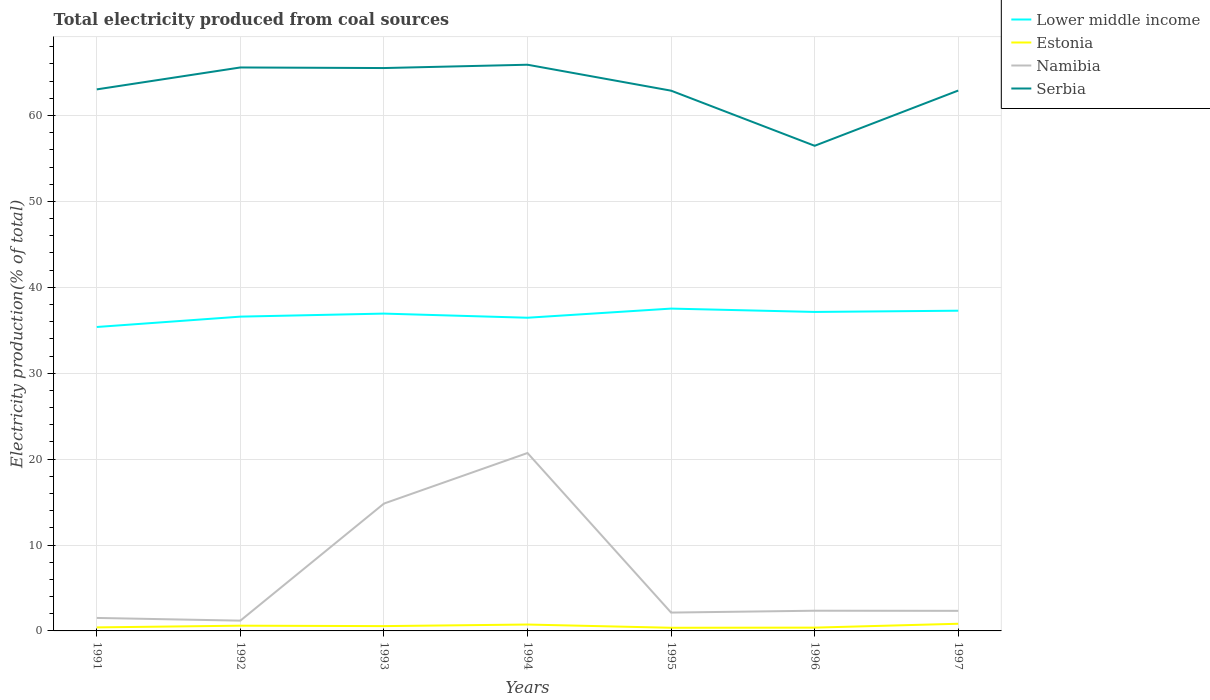Does the line corresponding to Serbia intersect with the line corresponding to Lower middle income?
Give a very brief answer. No. Is the number of lines equal to the number of legend labels?
Your response must be concise. Yes. Across all years, what is the maximum total electricity produced in Serbia?
Your response must be concise. 56.47. In which year was the total electricity produced in Serbia maximum?
Your answer should be very brief. 1996. What is the total total electricity produced in Lower middle income in the graph?
Offer a very short reply. 0.39. What is the difference between the highest and the second highest total electricity produced in Namibia?
Your response must be concise. 19.51. How many lines are there?
Provide a succinct answer. 4. Where does the legend appear in the graph?
Ensure brevity in your answer.  Top right. What is the title of the graph?
Make the answer very short. Total electricity produced from coal sources. Does "Switzerland" appear as one of the legend labels in the graph?
Provide a short and direct response. No. What is the Electricity production(% of total) in Lower middle income in 1991?
Your answer should be very brief. 35.38. What is the Electricity production(% of total) of Estonia in 1991?
Your response must be concise. 0.41. What is the Electricity production(% of total) in Namibia in 1991?
Your answer should be compact. 1.51. What is the Electricity production(% of total) in Serbia in 1991?
Your response must be concise. 63.04. What is the Electricity production(% of total) in Lower middle income in 1992?
Your response must be concise. 36.58. What is the Electricity production(% of total) of Estonia in 1992?
Your response must be concise. 0.61. What is the Electricity production(% of total) in Namibia in 1992?
Your response must be concise. 1.2. What is the Electricity production(% of total) in Serbia in 1992?
Your answer should be compact. 65.59. What is the Electricity production(% of total) of Lower middle income in 1993?
Make the answer very short. 36.94. What is the Electricity production(% of total) in Estonia in 1993?
Give a very brief answer. 0.56. What is the Electricity production(% of total) in Namibia in 1993?
Keep it short and to the point. 14.82. What is the Electricity production(% of total) of Serbia in 1993?
Keep it short and to the point. 65.52. What is the Electricity production(% of total) of Lower middle income in 1994?
Offer a very short reply. 36.46. What is the Electricity production(% of total) in Estonia in 1994?
Ensure brevity in your answer.  0.74. What is the Electricity production(% of total) in Namibia in 1994?
Your answer should be very brief. 20.71. What is the Electricity production(% of total) of Serbia in 1994?
Your answer should be compact. 65.91. What is the Electricity production(% of total) in Lower middle income in 1995?
Your answer should be very brief. 37.52. What is the Electricity production(% of total) of Estonia in 1995?
Provide a short and direct response. 0.37. What is the Electricity production(% of total) in Namibia in 1995?
Your response must be concise. 2.13. What is the Electricity production(% of total) of Serbia in 1995?
Offer a very short reply. 62.89. What is the Electricity production(% of total) of Lower middle income in 1996?
Give a very brief answer. 37.13. What is the Electricity production(% of total) in Estonia in 1996?
Your answer should be very brief. 0.38. What is the Electricity production(% of total) of Namibia in 1996?
Your answer should be compact. 2.35. What is the Electricity production(% of total) in Serbia in 1996?
Offer a very short reply. 56.47. What is the Electricity production(% of total) in Lower middle income in 1997?
Provide a succinct answer. 37.27. What is the Electricity production(% of total) of Estonia in 1997?
Offer a very short reply. 0.84. What is the Electricity production(% of total) in Namibia in 1997?
Keep it short and to the point. 2.34. What is the Electricity production(% of total) of Serbia in 1997?
Ensure brevity in your answer.  62.9. Across all years, what is the maximum Electricity production(% of total) in Lower middle income?
Ensure brevity in your answer.  37.52. Across all years, what is the maximum Electricity production(% of total) in Estonia?
Give a very brief answer. 0.84. Across all years, what is the maximum Electricity production(% of total) in Namibia?
Your answer should be compact. 20.71. Across all years, what is the maximum Electricity production(% of total) in Serbia?
Make the answer very short. 65.91. Across all years, what is the minimum Electricity production(% of total) in Lower middle income?
Your answer should be compact. 35.38. Across all years, what is the minimum Electricity production(% of total) in Estonia?
Your response must be concise. 0.37. Across all years, what is the minimum Electricity production(% of total) in Namibia?
Keep it short and to the point. 1.2. Across all years, what is the minimum Electricity production(% of total) in Serbia?
Offer a terse response. 56.47. What is the total Electricity production(% of total) of Lower middle income in the graph?
Your answer should be very brief. 257.28. What is the total Electricity production(% of total) in Estonia in the graph?
Make the answer very short. 3.91. What is the total Electricity production(% of total) of Namibia in the graph?
Your response must be concise. 45.07. What is the total Electricity production(% of total) of Serbia in the graph?
Your answer should be compact. 442.32. What is the difference between the Electricity production(% of total) in Lower middle income in 1991 and that in 1992?
Offer a very short reply. -1.21. What is the difference between the Electricity production(% of total) in Estonia in 1991 and that in 1992?
Your answer should be very brief. -0.2. What is the difference between the Electricity production(% of total) in Namibia in 1991 and that in 1992?
Your answer should be very brief. 0.32. What is the difference between the Electricity production(% of total) of Serbia in 1991 and that in 1992?
Your answer should be compact. -2.55. What is the difference between the Electricity production(% of total) of Lower middle income in 1991 and that in 1993?
Your answer should be compact. -1.56. What is the difference between the Electricity production(% of total) in Estonia in 1991 and that in 1993?
Offer a terse response. -0.15. What is the difference between the Electricity production(% of total) of Namibia in 1991 and that in 1993?
Offer a terse response. -13.31. What is the difference between the Electricity production(% of total) of Serbia in 1991 and that in 1993?
Keep it short and to the point. -2.48. What is the difference between the Electricity production(% of total) in Lower middle income in 1991 and that in 1994?
Make the answer very short. -1.08. What is the difference between the Electricity production(% of total) in Estonia in 1991 and that in 1994?
Keep it short and to the point. -0.33. What is the difference between the Electricity production(% of total) in Namibia in 1991 and that in 1994?
Your answer should be very brief. -19.2. What is the difference between the Electricity production(% of total) in Serbia in 1991 and that in 1994?
Provide a succinct answer. -2.87. What is the difference between the Electricity production(% of total) in Lower middle income in 1991 and that in 1995?
Ensure brevity in your answer.  -2.14. What is the difference between the Electricity production(% of total) in Estonia in 1991 and that in 1995?
Ensure brevity in your answer.  0.04. What is the difference between the Electricity production(% of total) in Namibia in 1991 and that in 1995?
Keep it short and to the point. -0.62. What is the difference between the Electricity production(% of total) of Lower middle income in 1991 and that in 1996?
Offer a terse response. -1.75. What is the difference between the Electricity production(% of total) in Estonia in 1991 and that in 1996?
Ensure brevity in your answer.  0.03. What is the difference between the Electricity production(% of total) of Namibia in 1991 and that in 1996?
Provide a succinct answer. -0.84. What is the difference between the Electricity production(% of total) of Serbia in 1991 and that in 1996?
Provide a succinct answer. 6.57. What is the difference between the Electricity production(% of total) of Lower middle income in 1991 and that in 1997?
Provide a succinct answer. -1.9. What is the difference between the Electricity production(% of total) of Estonia in 1991 and that in 1997?
Provide a succinct answer. -0.43. What is the difference between the Electricity production(% of total) in Namibia in 1991 and that in 1997?
Your answer should be very brief. -0.82. What is the difference between the Electricity production(% of total) in Serbia in 1991 and that in 1997?
Make the answer very short. 0.14. What is the difference between the Electricity production(% of total) in Lower middle income in 1992 and that in 1993?
Provide a short and direct response. -0.35. What is the difference between the Electricity production(% of total) in Estonia in 1992 and that in 1993?
Provide a short and direct response. 0.05. What is the difference between the Electricity production(% of total) in Namibia in 1992 and that in 1993?
Provide a succinct answer. -13.63. What is the difference between the Electricity production(% of total) in Serbia in 1992 and that in 1993?
Provide a succinct answer. 0.07. What is the difference between the Electricity production(% of total) in Lower middle income in 1992 and that in 1994?
Provide a succinct answer. 0.13. What is the difference between the Electricity production(% of total) in Estonia in 1992 and that in 1994?
Provide a short and direct response. -0.13. What is the difference between the Electricity production(% of total) in Namibia in 1992 and that in 1994?
Ensure brevity in your answer.  -19.51. What is the difference between the Electricity production(% of total) of Serbia in 1992 and that in 1994?
Keep it short and to the point. -0.32. What is the difference between the Electricity production(% of total) of Lower middle income in 1992 and that in 1995?
Offer a very short reply. -0.94. What is the difference between the Electricity production(% of total) in Estonia in 1992 and that in 1995?
Your answer should be compact. 0.24. What is the difference between the Electricity production(% of total) of Namibia in 1992 and that in 1995?
Make the answer very short. -0.94. What is the difference between the Electricity production(% of total) of Serbia in 1992 and that in 1995?
Your answer should be compact. 2.7. What is the difference between the Electricity production(% of total) in Lower middle income in 1992 and that in 1996?
Offer a very short reply. -0.55. What is the difference between the Electricity production(% of total) of Estonia in 1992 and that in 1996?
Provide a short and direct response. 0.22. What is the difference between the Electricity production(% of total) of Namibia in 1992 and that in 1996?
Offer a very short reply. -1.16. What is the difference between the Electricity production(% of total) in Serbia in 1992 and that in 1996?
Provide a short and direct response. 9.12. What is the difference between the Electricity production(% of total) of Lower middle income in 1992 and that in 1997?
Offer a very short reply. -0.69. What is the difference between the Electricity production(% of total) of Estonia in 1992 and that in 1997?
Give a very brief answer. -0.23. What is the difference between the Electricity production(% of total) of Namibia in 1992 and that in 1997?
Keep it short and to the point. -1.14. What is the difference between the Electricity production(% of total) of Serbia in 1992 and that in 1997?
Make the answer very short. 2.69. What is the difference between the Electricity production(% of total) in Lower middle income in 1993 and that in 1994?
Ensure brevity in your answer.  0.48. What is the difference between the Electricity production(% of total) in Estonia in 1993 and that in 1994?
Offer a terse response. -0.18. What is the difference between the Electricity production(% of total) of Namibia in 1993 and that in 1994?
Your answer should be compact. -5.88. What is the difference between the Electricity production(% of total) of Serbia in 1993 and that in 1994?
Give a very brief answer. -0.39. What is the difference between the Electricity production(% of total) of Lower middle income in 1993 and that in 1995?
Your answer should be compact. -0.58. What is the difference between the Electricity production(% of total) of Estonia in 1993 and that in 1995?
Make the answer very short. 0.19. What is the difference between the Electricity production(% of total) in Namibia in 1993 and that in 1995?
Your answer should be compact. 12.69. What is the difference between the Electricity production(% of total) in Serbia in 1993 and that in 1995?
Your answer should be very brief. 2.63. What is the difference between the Electricity production(% of total) of Lower middle income in 1993 and that in 1996?
Give a very brief answer. -0.19. What is the difference between the Electricity production(% of total) of Estonia in 1993 and that in 1996?
Your answer should be very brief. 0.17. What is the difference between the Electricity production(% of total) of Namibia in 1993 and that in 1996?
Your answer should be very brief. 12.47. What is the difference between the Electricity production(% of total) in Serbia in 1993 and that in 1996?
Your answer should be compact. 9.05. What is the difference between the Electricity production(% of total) in Lower middle income in 1993 and that in 1997?
Make the answer very short. -0.34. What is the difference between the Electricity production(% of total) in Estonia in 1993 and that in 1997?
Offer a terse response. -0.28. What is the difference between the Electricity production(% of total) of Namibia in 1993 and that in 1997?
Ensure brevity in your answer.  12.49. What is the difference between the Electricity production(% of total) in Serbia in 1993 and that in 1997?
Keep it short and to the point. 2.62. What is the difference between the Electricity production(% of total) in Lower middle income in 1994 and that in 1995?
Make the answer very short. -1.06. What is the difference between the Electricity production(% of total) of Estonia in 1994 and that in 1995?
Your answer should be compact. 0.37. What is the difference between the Electricity production(% of total) of Namibia in 1994 and that in 1995?
Provide a short and direct response. 18.57. What is the difference between the Electricity production(% of total) in Serbia in 1994 and that in 1995?
Keep it short and to the point. 3.02. What is the difference between the Electricity production(% of total) of Lower middle income in 1994 and that in 1996?
Your answer should be very brief. -0.67. What is the difference between the Electricity production(% of total) of Estonia in 1994 and that in 1996?
Your response must be concise. 0.36. What is the difference between the Electricity production(% of total) in Namibia in 1994 and that in 1996?
Offer a terse response. 18.36. What is the difference between the Electricity production(% of total) of Serbia in 1994 and that in 1996?
Your answer should be very brief. 9.44. What is the difference between the Electricity production(% of total) in Lower middle income in 1994 and that in 1997?
Provide a short and direct response. -0.82. What is the difference between the Electricity production(% of total) in Estonia in 1994 and that in 1997?
Offer a terse response. -0.09. What is the difference between the Electricity production(% of total) of Namibia in 1994 and that in 1997?
Offer a very short reply. 18.37. What is the difference between the Electricity production(% of total) in Serbia in 1994 and that in 1997?
Keep it short and to the point. 3.01. What is the difference between the Electricity production(% of total) of Lower middle income in 1995 and that in 1996?
Offer a very short reply. 0.39. What is the difference between the Electricity production(% of total) in Estonia in 1995 and that in 1996?
Your response must be concise. -0.02. What is the difference between the Electricity production(% of total) in Namibia in 1995 and that in 1996?
Provide a succinct answer. -0.22. What is the difference between the Electricity production(% of total) of Serbia in 1995 and that in 1996?
Make the answer very short. 6.42. What is the difference between the Electricity production(% of total) in Lower middle income in 1995 and that in 1997?
Your answer should be very brief. 0.25. What is the difference between the Electricity production(% of total) in Estonia in 1995 and that in 1997?
Keep it short and to the point. -0.47. What is the difference between the Electricity production(% of total) of Namibia in 1995 and that in 1997?
Keep it short and to the point. -0.2. What is the difference between the Electricity production(% of total) of Serbia in 1995 and that in 1997?
Keep it short and to the point. -0.01. What is the difference between the Electricity production(% of total) in Lower middle income in 1996 and that in 1997?
Make the answer very short. -0.14. What is the difference between the Electricity production(% of total) of Estonia in 1996 and that in 1997?
Provide a succinct answer. -0.45. What is the difference between the Electricity production(% of total) of Namibia in 1996 and that in 1997?
Provide a short and direct response. 0.02. What is the difference between the Electricity production(% of total) in Serbia in 1996 and that in 1997?
Your answer should be compact. -6.43. What is the difference between the Electricity production(% of total) in Lower middle income in 1991 and the Electricity production(% of total) in Estonia in 1992?
Make the answer very short. 34.77. What is the difference between the Electricity production(% of total) in Lower middle income in 1991 and the Electricity production(% of total) in Namibia in 1992?
Keep it short and to the point. 34.18. What is the difference between the Electricity production(% of total) in Lower middle income in 1991 and the Electricity production(% of total) in Serbia in 1992?
Provide a succinct answer. -30.21. What is the difference between the Electricity production(% of total) in Estonia in 1991 and the Electricity production(% of total) in Namibia in 1992?
Offer a very short reply. -0.79. What is the difference between the Electricity production(% of total) of Estonia in 1991 and the Electricity production(% of total) of Serbia in 1992?
Your response must be concise. -65.18. What is the difference between the Electricity production(% of total) in Namibia in 1991 and the Electricity production(% of total) in Serbia in 1992?
Keep it short and to the point. -64.08. What is the difference between the Electricity production(% of total) in Lower middle income in 1991 and the Electricity production(% of total) in Estonia in 1993?
Provide a succinct answer. 34.82. What is the difference between the Electricity production(% of total) in Lower middle income in 1991 and the Electricity production(% of total) in Namibia in 1993?
Provide a short and direct response. 20.55. What is the difference between the Electricity production(% of total) of Lower middle income in 1991 and the Electricity production(% of total) of Serbia in 1993?
Provide a short and direct response. -30.14. What is the difference between the Electricity production(% of total) of Estonia in 1991 and the Electricity production(% of total) of Namibia in 1993?
Your answer should be very brief. -14.41. What is the difference between the Electricity production(% of total) of Estonia in 1991 and the Electricity production(% of total) of Serbia in 1993?
Offer a very short reply. -65.11. What is the difference between the Electricity production(% of total) of Namibia in 1991 and the Electricity production(% of total) of Serbia in 1993?
Keep it short and to the point. -64.01. What is the difference between the Electricity production(% of total) of Lower middle income in 1991 and the Electricity production(% of total) of Estonia in 1994?
Offer a very short reply. 34.64. What is the difference between the Electricity production(% of total) in Lower middle income in 1991 and the Electricity production(% of total) in Namibia in 1994?
Offer a terse response. 14.67. What is the difference between the Electricity production(% of total) of Lower middle income in 1991 and the Electricity production(% of total) of Serbia in 1994?
Keep it short and to the point. -30.53. What is the difference between the Electricity production(% of total) in Estonia in 1991 and the Electricity production(% of total) in Namibia in 1994?
Ensure brevity in your answer.  -20.3. What is the difference between the Electricity production(% of total) of Estonia in 1991 and the Electricity production(% of total) of Serbia in 1994?
Provide a short and direct response. -65.5. What is the difference between the Electricity production(% of total) of Namibia in 1991 and the Electricity production(% of total) of Serbia in 1994?
Keep it short and to the point. -64.4. What is the difference between the Electricity production(% of total) in Lower middle income in 1991 and the Electricity production(% of total) in Estonia in 1995?
Provide a short and direct response. 35.01. What is the difference between the Electricity production(% of total) in Lower middle income in 1991 and the Electricity production(% of total) in Namibia in 1995?
Keep it short and to the point. 33.24. What is the difference between the Electricity production(% of total) in Lower middle income in 1991 and the Electricity production(% of total) in Serbia in 1995?
Your answer should be very brief. -27.51. What is the difference between the Electricity production(% of total) of Estonia in 1991 and the Electricity production(% of total) of Namibia in 1995?
Your answer should be compact. -1.72. What is the difference between the Electricity production(% of total) in Estonia in 1991 and the Electricity production(% of total) in Serbia in 1995?
Your response must be concise. -62.48. What is the difference between the Electricity production(% of total) of Namibia in 1991 and the Electricity production(% of total) of Serbia in 1995?
Offer a very short reply. -61.38. What is the difference between the Electricity production(% of total) of Lower middle income in 1991 and the Electricity production(% of total) of Estonia in 1996?
Provide a short and direct response. 34.99. What is the difference between the Electricity production(% of total) in Lower middle income in 1991 and the Electricity production(% of total) in Namibia in 1996?
Your answer should be very brief. 33.03. What is the difference between the Electricity production(% of total) in Lower middle income in 1991 and the Electricity production(% of total) in Serbia in 1996?
Keep it short and to the point. -21.09. What is the difference between the Electricity production(% of total) in Estonia in 1991 and the Electricity production(% of total) in Namibia in 1996?
Ensure brevity in your answer.  -1.94. What is the difference between the Electricity production(% of total) in Estonia in 1991 and the Electricity production(% of total) in Serbia in 1996?
Offer a very short reply. -56.06. What is the difference between the Electricity production(% of total) in Namibia in 1991 and the Electricity production(% of total) in Serbia in 1996?
Your response must be concise. -54.96. What is the difference between the Electricity production(% of total) of Lower middle income in 1991 and the Electricity production(% of total) of Estonia in 1997?
Your response must be concise. 34.54. What is the difference between the Electricity production(% of total) in Lower middle income in 1991 and the Electricity production(% of total) in Namibia in 1997?
Keep it short and to the point. 33.04. What is the difference between the Electricity production(% of total) of Lower middle income in 1991 and the Electricity production(% of total) of Serbia in 1997?
Make the answer very short. -27.52. What is the difference between the Electricity production(% of total) in Estonia in 1991 and the Electricity production(% of total) in Namibia in 1997?
Offer a very short reply. -1.93. What is the difference between the Electricity production(% of total) of Estonia in 1991 and the Electricity production(% of total) of Serbia in 1997?
Your answer should be very brief. -62.49. What is the difference between the Electricity production(% of total) in Namibia in 1991 and the Electricity production(% of total) in Serbia in 1997?
Give a very brief answer. -61.39. What is the difference between the Electricity production(% of total) of Lower middle income in 1992 and the Electricity production(% of total) of Estonia in 1993?
Provide a short and direct response. 36.03. What is the difference between the Electricity production(% of total) in Lower middle income in 1992 and the Electricity production(% of total) in Namibia in 1993?
Your response must be concise. 21.76. What is the difference between the Electricity production(% of total) of Lower middle income in 1992 and the Electricity production(% of total) of Serbia in 1993?
Your response must be concise. -28.94. What is the difference between the Electricity production(% of total) in Estonia in 1992 and the Electricity production(% of total) in Namibia in 1993?
Give a very brief answer. -14.22. What is the difference between the Electricity production(% of total) of Estonia in 1992 and the Electricity production(% of total) of Serbia in 1993?
Ensure brevity in your answer.  -64.91. What is the difference between the Electricity production(% of total) of Namibia in 1992 and the Electricity production(% of total) of Serbia in 1993?
Your response must be concise. -64.33. What is the difference between the Electricity production(% of total) in Lower middle income in 1992 and the Electricity production(% of total) in Estonia in 1994?
Your answer should be compact. 35.84. What is the difference between the Electricity production(% of total) of Lower middle income in 1992 and the Electricity production(% of total) of Namibia in 1994?
Your answer should be very brief. 15.88. What is the difference between the Electricity production(% of total) of Lower middle income in 1992 and the Electricity production(% of total) of Serbia in 1994?
Your answer should be very brief. -29.32. What is the difference between the Electricity production(% of total) in Estonia in 1992 and the Electricity production(% of total) in Namibia in 1994?
Keep it short and to the point. -20.1. What is the difference between the Electricity production(% of total) in Estonia in 1992 and the Electricity production(% of total) in Serbia in 1994?
Provide a short and direct response. -65.3. What is the difference between the Electricity production(% of total) of Namibia in 1992 and the Electricity production(% of total) of Serbia in 1994?
Keep it short and to the point. -64.71. What is the difference between the Electricity production(% of total) of Lower middle income in 1992 and the Electricity production(% of total) of Estonia in 1995?
Provide a succinct answer. 36.22. What is the difference between the Electricity production(% of total) of Lower middle income in 1992 and the Electricity production(% of total) of Namibia in 1995?
Your response must be concise. 34.45. What is the difference between the Electricity production(% of total) of Lower middle income in 1992 and the Electricity production(% of total) of Serbia in 1995?
Provide a succinct answer. -26.3. What is the difference between the Electricity production(% of total) of Estonia in 1992 and the Electricity production(% of total) of Namibia in 1995?
Offer a terse response. -1.53. What is the difference between the Electricity production(% of total) of Estonia in 1992 and the Electricity production(% of total) of Serbia in 1995?
Provide a succinct answer. -62.28. What is the difference between the Electricity production(% of total) of Namibia in 1992 and the Electricity production(% of total) of Serbia in 1995?
Keep it short and to the point. -61.69. What is the difference between the Electricity production(% of total) of Lower middle income in 1992 and the Electricity production(% of total) of Estonia in 1996?
Your answer should be very brief. 36.2. What is the difference between the Electricity production(% of total) of Lower middle income in 1992 and the Electricity production(% of total) of Namibia in 1996?
Keep it short and to the point. 34.23. What is the difference between the Electricity production(% of total) in Lower middle income in 1992 and the Electricity production(% of total) in Serbia in 1996?
Provide a succinct answer. -19.89. What is the difference between the Electricity production(% of total) in Estonia in 1992 and the Electricity production(% of total) in Namibia in 1996?
Your answer should be very brief. -1.74. What is the difference between the Electricity production(% of total) of Estonia in 1992 and the Electricity production(% of total) of Serbia in 1996?
Provide a succinct answer. -55.86. What is the difference between the Electricity production(% of total) in Namibia in 1992 and the Electricity production(% of total) in Serbia in 1996?
Offer a very short reply. -55.27. What is the difference between the Electricity production(% of total) of Lower middle income in 1992 and the Electricity production(% of total) of Estonia in 1997?
Give a very brief answer. 35.75. What is the difference between the Electricity production(% of total) in Lower middle income in 1992 and the Electricity production(% of total) in Namibia in 1997?
Provide a succinct answer. 34.25. What is the difference between the Electricity production(% of total) of Lower middle income in 1992 and the Electricity production(% of total) of Serbia in 1997?
Offer a terse response. -26.32. What is the difference between the Electricity production(% of total) in Estonia in 1992 and the Electricity production(% of total) in Namibia in 1997?
Ensure brevity in your answer.  -1.73. What is the difference between the Electricity production(% of total) in Estonia in 1992 and the Electricity production(% of total) in Serbia in 1997?
Ensure brevity in your answer.  -62.29. What is the difference between the Electricity production(% of total) in Namibia in 1992 and the Electricity production(% of total) in Serbia in 1997?
Make the answer very short. -61.71. What is the difference between the Electricity production(% of total) in Lower middle income in 1993 and the Electricity production(% of total) in Estonia in 1994?
Offer a terse response. 36.19. What is the difference between the Electricity production(% of total) of Lower middle income in 1993 and the Electricity production(% of total) of Namibia in 1994?
Ensure brevity in your answer.  16.23. What is the difference between the Electricity production(% of total) in Lower middle income in 1993 and the Electricity production(% of total) in Serbia in 1994?
Ensure brevity in your answer.  -28.97. What is the difference between the Electricity production(% of total) of Estonia in 1993 and the Electricity production(% of total) of Namibia in 1994?
Make the answer very short. -20.15. What is the difference between the Electricity production(% of total) of Estonia in 1993 and the Electricity production(% of total) of Serbia in 1994?
Your response must be concise. -65.35. What is the difference between the Electricity production(% of total) in Namibia in 1993 and the Electricity production(% of total) in Serbia in 1994?
Your answer should be very brief. -51.08. What is the difference between the Electricity production(% of total) of Lower middle income in 1993 and the Electricity production(% of total) of Estonia in 1995?
Make the answer very short. 36.57. What is the difference between the Electricity production(% of total) of Lower middle income in 1993 and the Electricity production(% of total) of Namibia in 1995?
Make the answer very short. 34.8. What is the difference between the Electricity production(% of total) of Lower middle income in 1993 and the Electricity production(% of total) of Serbia in 1995?
Your response must be concise. -25.95. What is the difference between the Electricity production(% of total) of Estonia in 1993 and the Electricity production(% of total) of Namibia in 1995?
Your response must be concise. -1.58. What is the difference between the Electricity production(% of total) in Estonia in 1993 and the Electricity production(% of total) in Serbia in 1995?
Offer a terse response. -62.33. What is the difference between the Electricity production(% of total) of Namibia in 1993 and the Electricity production(% of total) of Serbia in 1995?
Offer a terse response. -48.06. What is the difference between the Electricity production(% of total) of Lower middle income in 1993 and the Electricity production(% of total) of Estonia in 1996?
Provide a succinct answer. 36.55. What is the difference between the Electricity production(% of total) in Lower middle income in 1993 and the Electricity production(% of total) in Namibia in 1996?
Keep it short and to the point. 34.59. What is the difference between the Electricity production(% of total) of Lower middle income in 1993 and the Electricity production(% of total) of Serbia in 1996?
Your answer should be compact. -19.53. What is the difference between the Electricity production(% of total) of Estonia in 1993 and the Electricity production(% of total) of Namibia in 1996?
Your response must be concise. -1.79. What is the difference between the Electricity production(% of total) in Estonia in 1993 and the Electricity production(% of total) in Serbia in 1996?
Provide a succinct answer. -55.91. What is the difference between the Electricity production(% of total) of Namibia in 1993 and the Electricity production(% of total) of Serbia in 1996?
Offer a terse response. -41.65. What is the difference between the Electricity production(% of total) of Lower middle income in 1993 and the Electricity production(% of total) of Estonia in 1997?
Give a very brief answer. 36.1. What is the difference between the Electricity production(% of total) of Lower middle income in 1993 and the Electricity production(% of total) of Namibia in 1997?
Ensure brevity in your answer.  34.6. What is the difference between the Electricity production(% of total) of Lower middle income in 1993 and the Electricity production(% of total) of Serbia in 1997?
Provide a short and direct response. -25.96. What is the difference between the Electricity production(% of total) in Estonia in 1993 and the Electricity production(% of total) in Namibia in 1997?
Provide a short and direct response. -1.78. What is the difference between the Electricity production(% of total) of Estonia in 1993 and the Electricity production(% of total) of Serbia in 1997?
Provide a succinct answer. -62.34. What is the difference between the Electricity production(% of total) of Namibia in 1993 and the Electricity production(% of total) of Serbia in 1997?
Offer a very short reply. -48.08. What is the difference between the Electricity production(% of total) in Lower middle income in 1994 and the Electricity production(% of total) in Estonia in 1995?
Your response must be concise. 36.09. What is the difference between the Electricity production(% of total) in Lower middle income in 1994 and the Electricity production(% of total) in Namibia in 1995?
Keep it short and to the point. 34.32. What is the difference between the Electricity production(% of total) of Lower middle income in 1994 and the Electricity production(% of total) of Serbia in 1995?
Offer a terse response. -26.43. What is the difference between the Electricity production(% of total) in Estonia in 1994 and the Electricity production(% of total) in Namibia in 1995?
Offer a very short reply. -1.39. What is the difference between the Electricity production(% of total) of Estonia in 1994 and the Electricity production(% of total) of Serbia in 1995?
Your response must be concise. -62.14. What is the difference between the Electricity production(% of total) of Namibia in 1994 and the Electricity production(% of total) of Serbia in 1995?
Offer a terse response. -42.18. What is the difference between the Electricity production(% of total) of Lower middle income in 1994 and the Electricity production(% of total) of Estonia in 1996?
Your answer should be very brief. 36.07. What is the difference between the Electricity production(% of total) in Lower middle income in 1994 and the Electricity production(% of total) in Namibia in 1996?
Offer a very short reply. 34.1. What is the difference between the Electricity production(% of total) of Lower middle income in 1994 and the Electricity production(% of total) of Serbia in 1996?
Your answer should be compact. -20.02. What is the difference between the Electricity production(% of total) of Estonia in 1994 and the Electricity production(% of total) of Namibia in 1996?
Make the answer very short. -1.61. What is the difference between the Electricity production(% of total) of Estonia in 1994 and the Electricity production(% of total) of Serbia in 1996?
Provide a succinct answer. -55.73. What is the difference between the Electricity production(% of total) in Namibia in 1994 and the Electricity production(% of total) in Serbia in 1996?
Keep it short and to the point. -35.76. What is the difference between the Electricity production(% of total) in Lower middle income in 1994 and the Electricity production(% of total) in Estonia in 1997?
Keep it short and to the point. 35.62. What is the difference between the Electricity production(% of total) in Lower middle income in 1994 and the Electricity production(% of total) in Namibia in 1997?
Keep it short and to the point. 34.12. What is the difference between the Electricity production(% of total) in Lower middle income in 1994 and the Electricity production(% of total) in Serbia in 1997?
Offer a very short reply. -26.45. What is the difference between the Electricity production(% of total) in Estonia in 1994 and the Electricity production(% of total) in Namibia in 1997?
Your answer should be compact. -1.59. What is the difference between the Electricity production(% of total) in Estonia in 1994 and the Electricity production(% of total) in Serbia in 1997?
Give a very brief answer. -62.16. What is the difference between the Electricity production(% of total) in Namibia in 1994 and the Electricity production(% of total) in Serbia in 1997?
Offer a terse response. -42.19. What is the difference between the Electricity production(% of total) of Lower middle income in 1995 and the Electricity production(% of total) of Estonia in 1996?
Offer a terse response. 37.14. What is the difference between the Electricity production(% of total) in Lower middle income in 1995 and the Electricity production(% of total) in Namibia in 1996?
Make the answer very short. 35.17. What is the difference between the Electricity production(% of total) of Lower middle income in 1995 and the Electricity production(% of total) of Serbia in 1996?
Keep it short and to the point. -18.95. What is the difference between the Electricity production(% of total) of Estonia in 1995 and the Electricity production(% of total) of Namibia in 1996?
Your response must be concise. -1.98. What is the difference between the Electricity production(% of total) of Estonia in 1995 and the Electricity production(% of total) of Serbia in 1996?
Offer a very short reply. -56.1. What is the difference between the Electricity production(% of total) in Namibia in 1995 and the Electricity production(% of total) in Serbia in 1996?
Offer a terse response. -54.34. What is the difference between the Electricity production(% of total) of Lower middle income in 1995 and the Electricity production(% of total) of Estonia in 1997?
Make the answer very short. 36.69. What is the difference between the Electricity production(% of total) of Lower middle income in 1995 and the Electricity production(% of total) of Namibia in 1997?
Keep it short and to the point. 35.18. What is the difference between the Electricity production(% of total) in Lower middle income in 1995 and the Electricity production(% of total) in Serbia in 1997?
Your answer should be very brief. -25.38. What is the difference between the Electricity production(% of total) in Estonia in 1995 and the Electricity production(% of total) in Namibia in 1997?
Provide a succinct answer. -1.97. What is the difference between the Electricity production(% of total) of Estonia in 1995 and the Electricity production(% of total) of Serbia in 1997?
Ensure brevity in your answer.  -62.53. What is the difference between the Electricity production(% of total) of Namibia in 1995 and the Electricity production(% of total) of Serbia in 1997?
Give a very brief answer. -60.77. What is the difference between the Electricity production(% of total) in Lower middle income in 1996 and the Electricity production(% of total) in Estonia in 1997?
Provide a succinct answer. 36.3. What is the difference between the Electricity production(% of total) of Lower middle income in 1996 and the Electricity production(% of total) of Namibia in 1997?
Your response must be concise. 34.79. What is the difference between the Electricity production(% of total) in Lower middle income in 1996 and the Electricity production(% of total) in Serbia in 1997?
Offer a terse response. -25.77. What is the difference between the Electricity production(% of total) in Estonia in 1996 and the Electricity production(% of total) in Namibia in 1997?
Offer a terse response. -1.95. What is the difference between the Electricity production(% of total) of Estonia in 1996 and the Electricity production(% of total) of Serbia in 1997?
Your response must be concise. -62.52. What is the difference between the Electricity production(% of total) of Namibia in 1996 and the Electricity production(% of total) of Serbia in 1997?
Keep it short and to the point. -60.55. What is the average Electricity production(% of total) of Lower middle income per year?
Give a very brief answer. 36.75. What is the average Electricity production(% of total) of Estonia per year?
Keep it short and to the point. 0.56. What is the average Electricity production(% of total) of Namibia per year?
Your answer should be very brief. 6.44. What is the average Electricity production(% of total) of Serbia per year?
Offer a very short reply. 63.19. In the year 1991, what is the difference between the Electricity production(% of total) of Lower middle income and Electricity production(% of total) of Estonia?
Keep it short and to the point. 34.97. In the year 1991, what is the difference between the Electricity production(% of total) in Lower middle income and Electricity production(% of total) in Namibia?
Give a very brief answer. 33.87. In the year 1991, what is the difference between the Electricity production(% of total) in Lower middle income and Electricity production(% of total) in Serbia?
Provide a succinct answer. -27.66. In the year 1991, what is the difference between the Electricity production(% of total) of Estonia and Electricity production(% of total) of Namibia?
Ensure brevity in your answer.  -1.1. In the year 1991, what is the difference between the Electricity production(% of total) in Estonia and Electricity production(% of total) in Serbia?
Offer a very short reply. -62.63. In the year 1991, what is the difference between the Electricity production(% of total) of Namibia and Electricity production(% of total) of Serbia?
Keep it short and to the point. -61.53. In the year 1992, what is the difference between the Electricity production(% of total) of Lower middle income and Electricity production(% of total) of Estonia?
Make the answer very short. 35.98. In the year 1992, what is the difference between the Electricity production(% of total) of Lower middle income and Electricity production(% of total) of Namibia?
Your answer should be compact. 35.39. In the year 1992, what is the difference between the Electricity production(% of total) in Lower middle income and Electricity production(% of total) in Serbia?
Offer a terse response. -29. In the year 1992, what is the difference between the Electricity production(% of total) of Estonia and Electricity production(% of total) of Namibia?
Your answer should be compact. -0.59. In the year 1992, what is the difference between the Electricity production(% of total) of Estonia and Electricity production(% of total) of Serbia?
Offer a terse response. -64.98. In the year 1992, what is the difference between the Electricity production(% of total) in Namibia and Electricity production(% of total) in Serbia?
Your answer should be very brief. -64.39. In the year 1993, what is the difference between the Electricity production(% of total) in Lower middle income and Electricity production(% of total) in Estonia?
Give a very brief answer. 36.38. In the year 1993, what is the difference between the Electricity production(% of total) of Lower middle income and Electricity production(% of total) of Namibia?
Provide a short and direct response. 22.11. In the year 1993, what is the difference between the Electricity production(% of total) of Lower middle income and Electricity production(% of total) of Serbia?
Give a very brief answer. -28.58. In the year 1993, what is the difference between the Electricity production(% of total) of Estonia and Electricity production(% of total) of Namibia?
Ensure brevity in your answer.  -14.26. In the year 1993, what is the difference between the Electricity production(% of total) in Estonia and Electricity production(% of total) in Serbia?
Give a very brief answer. -64.96. In the year 1993, what is the difference between the Electricity production(% of total) in Namibia and Electricity production(% of total) in Serbia?
Give a very brief answer. -50.7. In the year 1994, what is the difference between the Electricity production(% of total) in Lower middle income and Electricity production(% of total) in Estonia?
Keep it short and to the point. 35.71. In the year 1994, what is the difference between the Electricity production(% of total) of Lower middle income and Electricity production(% of total) of Namibia?
Make the answer very short. 15.75. In the year 1994, what is the difference between the Electricity production(% of total) in Lower middle income and Electricity production(% of total) in Serbia?
Make the answer very short. -29.45. In the year 1994, what is the difference between the Electricity production(% of total) of Estonia and Electricity production(% of total) of Namibia?
Give a very brief answer. -19.97. In the year 1994, what is the difference between the Electricity production(% of total) of Estonia and Electricity production(% of total) of Serbia?
Your answer should be compact. -65.16. In the year 1994, what is the difference between the Electricity production(% of total) of Namibia and Electricity production(% of total) of Serbia?
Give a very brief answer. -45.2. In the year 1995, what is the difference between the Electricity production(% of total) in Lower middle income and Electricity production(% of total) in Estonia?
Keep it short and to the point. 37.15. In the year 1995, what is the difference between the Electricity production(% of total) of Lower middle income and Electricity production(% of total) of Namibia?
Provide a succinct answer. 35.39. In the year 1995, what is the difference between the Electricity production(% of total) in Lower middle income and Electricity production(% of total) in Serbia?
Keep it short and to the point. -25.37. In the year 1995, what is the difference between the Electricity production(% of total) in Estonia and Electricity production(% of total) in Namibia?
Offer a very short reply. -1.77. In the year 1995, what is the difference between the Electricity production(% of total) of Estonia and Electricity production(% of total) of Serbia?
Provide a short and direct response. -62.52. In the year 1995, what is the difference between the Electricity production(% of total) in Namibia and Electricity production(% of total) in Serbia?
Offer a terse response. -60.75. In the year 1996, what is the difference between the Electricity production(% of total) of Lower middle income and Electricity production(% of total) of Estonia?
Give a very brief answer. 36.75. In the year 1996, what is the difference between the Electricity production(% of total) of Lower middle income and Electricity production(% of total) of Namibia?
Give a very brief answer. 34.78. In the year 1996, what is the difference between the Electricity production(% of total) of Lower middle income and Electricity production(% of total) of Serbia?
Your answer should be very brief. -19.34. In the year 1996, what is the difference between the Electricity production(% of total) of Estonia and Electricity production(% of total) of Namibia?
Offer a very short reply. -1.97. In the year 1996, what is the difference between the Electricity production(% of total) in Estonia and Electricity production(% of total) in Serbia?
Provide a short and direct response. -56.09. In the year 1996, what is the difference between the Electricity production(% of total) in Namibia and Electricity production(% of total) in Serbia?
Make the answer very short. -54.12. In the year 1997, what is the difference between the Electricity production(% of total) in Lower middle income and Electricity production(% of total) in Estonia?
Offer a very short reply. 36.44. In the year 1997, what is the difference between the Electricity production(% of total) in Lower middle income and Electricity production(% of total) in Namibia?
Your answer should be very brief. 34.94. In the year 1997, what is the difference between the Electricity production(% of total) of Lower middle income and Electricity production(% of total) of Serbia?
Your answer should be compact. -25.63. In the year 1997, what is the difference between the Electricity production(% of total) of Estonia and Electricity production(% of total) of Namibia?
Your answer should be compact. -1.5. In the year 1997, what is the difference between the Electricity production(% of total) in Estonia and Electricity production(% of total) in Serbia?
Provide a succinct answer. -62.07. In the year 1997, what is the difference between the Electricity production(% of total) of Namibia and Electricity production(% of total) of Serbia?
Offer a terse response. -60.57. What is the ratio of the Electricity production(% of total) of Lower middle income in 1991 to that in 1992?
Your response must be concise. 0.97. What is the ratio of the Electricity production(% of total) in Estonia in 1991 to that in 1992?
Give a very brief answer. 0.67. What is the ratio of the Electricity production(% of total) in Namibia in 1991 to that in 1992?
Give a very brief answer. 1.26. What is the ratio of the Electricity production(% of total) in Serbia in 1991 to that in 1992?
Offer a terse response. 0.96. What is the ratio of the Electricity production(% of total) of Lower middle income in 1991 to that in 1993?
Your answer should be very brief. 0.96. What is the ratio of the Electricity production(% of total) of Estonia in 1991 to that in 1993?
Make the answer very short. 0.73. What is the ratio of the Electricity production(% of total) in Namibia in 1991 to that in 1993?
Your answer should be compact. 0.1. What is the ratio of the Electricity production(% of total) in Serbia in 1991 to that in 1993?
Ensure brevity in your answer.  0.96. What is the ratio of the Electricity production(% of total) in Lower middle income in 1991 to that in 1994?
Provide a succinct answer. 0.97. What is the ratio of the Electricity production(% of total) in Estonia in 1991 to that in 1994?
Provide a short and direct response. 0.55. What is the ratio of the Electricity production(% of total) in Namibia in 1991 to that in 1994?
Your response must be concise. 0.07. What is the ratio of the Electricity production(% of total) in Serbia in 1991 to that in 1994?
Your answer should be very brief. 0.96. What is the ratio of the Electricity production(% of total) of Lower middle income in 1991 to that in 1995?
Ensure brevity in your answer.  0.94. What is the ratio of the Electricity production(% of total) in Estonia in 1991 to that in 1995?
Make the answer very short. 1.11. What is the ratio of the Electricity production(% of total) of Namibia in 1991 to that in 1995?
Your answer should be compact. 0.71. What is the ratio of the Electricity production(% of total) of Serbia in 1991 to that in 1995?
Your response must be concise. 1. What is the ratio of the Electricity production(% of total) of Lower middle income in 1991 to that in 1996?
Keep it short and to the point. 0.95. What is the ratio of the Electricity production(% of total) of Estonia in 1991 to that in 1996?
Offer a terse response. 1.07. What is the ratio of the Electricity production(% of total) in Namibia in 1991 to that in 1996?
Provide a short and direct response. 0.64. What is the ratio of the Electricity production(% of total) in Serbia in 1991 to that in 1996?
Your answer should be very brief. 1.12. What is the ratio of the Electricity production(% of total) of Lower middle income in 1991 to that in 1997?
Ensure brevity in your answer.  0.95. What is the ratio of the Electricity production(% of total) of Estonia in 1991 to that in 1997?
Provide a succinct answer. 0.49. What is the ratio of the Electricity production(% of total) in Namibia in 1991 to that in 1997?
Give a very brief answer. 0.65. What is the ratio of the Electricity production(% of total) in Estonia in 1992 to that in 1993?
Give a very brief answer. 1.09. What is the ratio of the Electricity production(% of total) of Namibia in 1992 to that in 1993?
Provide a succinct answer. 0.08. What is the ratio of the Electricity production(% of total) of Serbia in 1992 to that in 1993?
Your response must be concise. 1. What is the ratio of the Electricity production(% of total) in Estonia in 1992 to that in 1994?
Your answer should be very brief. 0.82. What is the ratio of the Electricity production(% of total) of Namibia in 1992 to that in 1994?
Give a very brief answer. 0.06. What is the ratio of the Electricity production(% of total) in Lower middle income in 1992 to that in 1995?
Provide a succinct answer. 0.98. What is the ratio of the Electricity production(% of total) in Estonia in 1992 to that in 1995?
Your response must be concise. 1.65. What is the ratio of the Electricity production(% of total) in Namibia in 1992 to that in 1995?
Your response must be concise. 0.56. What is the ratio of the Electricity production(% of total) of Serbia in 1992 to that in 1995?
Give a very brief answer. 1.04. What is the ratio of the Electricity production(% of total) of Estonia in 1992 to that in 1996?
Offer a terse response. 1.58. What is the ratio of the Electricity production(% of total) of Namibia in 1992 to that in 1996?
Give a very brief answer. 0.51. What is the ratio of the Electricity production(% of total) of Serbia in 1992 to that in 1996?
Offer a terse response. 1.16. What is the ratio of the Electricity production(% of total) in Lower middle income in 1992 to that in 1997?
Keep it short and to the point. 0.98. What is the ratio of the Electricity production(% of total) of Estonia in 1992 to that in 1997?
Give a very brief answer. 0.73. What is the ratio of the Electricity production(% of total) of Namibia in 1992 to that in 1997?
Offer a very short reply. 0.51. What is the ratio of the Electricity production(% of total) of Serbia in 1992 to that in 1997?
Offer a terse response. 1.04. What is the ratio of the Electricity production(% of total) in Lower middle income in 1993 to that in 1994?
Provide a succinct answer. 1.01. What is the ratio of the Electricity production(% of total) in Estonia in 1993 to that in 1994?
Make the answer very short. 0.75. What is the ratio of the Electricity production(% of total) in Namibia in 1993 to that in 1994?
Provide a succinct answer. 0.72. What is the ratio of the Electricity production(% of total) of Lower middle income in 1993 to that in 1995?
Give a very brief answer. 0.98. What is the ratio of the Electricity production(% of total) in Estonia in 1993 to that in 1995?
Offer a terse response. 1.52. What is the ratio of the Electricity production(% of total) of Namibia in 1993 to that in 1995?
Provide a short and direct response. 6.94. What is the ratio of the Electricity production(% of total) of Serbia in 1993 to that in 1995?
Keep it short and to the point. 1.04. What is the ratio of the Electricity production(% of total) in Lower middle income in 1993 to that in 1996?
Your response must be concise. 0.99. What is the ratio of the Electricity production(% of total) of Estonia in 1993 to that in 1996?
Give a very brief answer. 1.45. What is the ratio of the Electricity production(% of total) of Namibia in 1993 to that in 1996?
Give a very brief answer. 6.3. What is the ratio of the Electricity production(% of total) in Serbia in 1993 to that in 1996?
Provide a succinct answer. 1.16. What is the ratio of the Electricity production(% of total) of Estonia in 1993 to that in 1997?
Offer a very short reply. 0.67. What is the ratio of the Electricity production(% of total) in Namibia in 1993 to that in 1997?
Provide a short and direct response. 6.34. What is the ratio of the Electricity production(% of total) in Serbia in 1993 to that in 1997?
Your answer should be very brief. 1.04. What is the ratio of the Electricity production(% of total) in Lower middle income in 1994 to that in 1995?
Your answer should be compact. 0.97. What is the ratio of the Electricity production(% of total) in Estonia in 1994 to that in 1995?
Ensure brevity in your answer.  2.02. What is the ratio of the Electricity production(% of total) of Namibia in 1994 to that in 1995?
Provide a succinct answer. 9.7. What is the ratio of the Electricity production(% of total) of Serbia in 1994 to that in 1995?
Ensure brevity in your answer.  1.05. What is the ratio of the Electricity production(% of total) in Lower middle income in 1994 to that in 1996?
Provide a short and direct response. 0.98. What is the ratio of the Electricity production(% of total) of Estonia in 1994 to that in 1996?
Ensure brevity in your answer.  1.93. What is the ratio of the Electricity production(% of total) in Namibia in 1994 to that in 1996?
Your answer should be compact. 8.81. What is the ratio of the Electricity production(% of total) of Serbia in 1994 to that in 1996?
Ensure brevity in your answer.  1.17. What is the ratio of the Electricity production(% of total) of Estonia in 1994 to that in 1997?
Your answer should be very brief. 0.89. What is the ratio of the Electricity production(% of total) in Namibia in 1994 to that in 1997?
Give a very brief answer. 8.86. What is the ratio of the Electricity production(% of total) in Serbia in 1994 to that in 1997?
Provide a succinct answer. 1.05. What is the ratio of the Electricity production(% of total) of Lower middle income in 1995 to that in 1996?
Your response must be concise. 1.01. What is the ratio of the Electricity production(% of total) in Estonia in 1995 to that in 1996?
Your answer should be compact. 0.96. What is the ratio of the Electricity production(% of total) of Namibia in 1995 to that in 1996?
Your answer should be very brief. 0.91. What is the ratio of the Electricity production(% of total) in Serbia in 1995 to that in 1996?
Offer a terse response. 1.11. What is the ratio of the Electricity production(% of total) of Lower middle income in 1995 to that in 1997?
Ensure brevity in your answer.  1.01. What is the ratio of the Electricity production(% of total) in Estonia in 1995 to that in 1997?
Give a very brief answer. 0.44. What is the ratio of the Electricity production(% of total) of Namibia in 1995 to that in 1997?
Offer a terse response. 0.91. What is the ratio of the Electricity production(% of total) in Estonia in 1996 to that in 1997?
Provide a succinct answer. 0.46. What is the ratio of the Electricity production(% of total) in Serbia in 1996 to that in 1997?
Offer a terse response. 0.9. What is the difference between the highest and the second highest Electricity production(% of total) of Lower middle income?
Keep it short and to the point. 0.25. What is the difference between the highest and the second highest Electricity production(% of total) in Estonia?
Ensure brevity in your answer.  0.09. What is the difference between the highest and the second highest Electricity production(% of total) in Namibia?
Keep it short and to the point. 5.88. What is the difference between the highest and the second highest Electricity production(% of total) of Serbia?
Your response must be concise. 0.32. What is the difference between the highest and the lowest Electricity production(% of total) in Lower middle income?
Make the answer very short. 2.14. What is the difference between the highest and the lowest Electricity production(% of total) of Estonia?
Give a very brief answer. 0.47. What is the difference between the highest and the lowest Electricity production(% of total) of Namibia?
Your response must be concise. 19.51. What is the difference between the highest and the lowest Electricity production(% of total) of Serbia?
Keep it short and to the point. 9.44. 